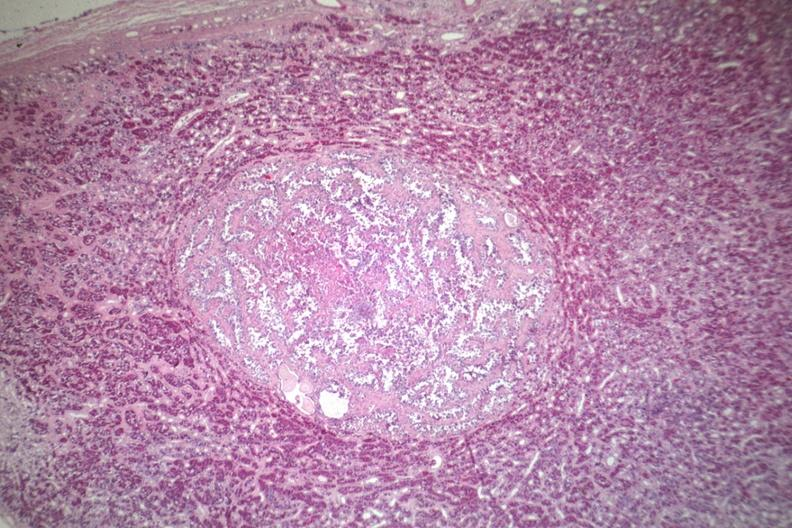does cytomegalovirus show well circumscribed papillary lesion see for high mag?
Answer the question using a single word or phrase. No 